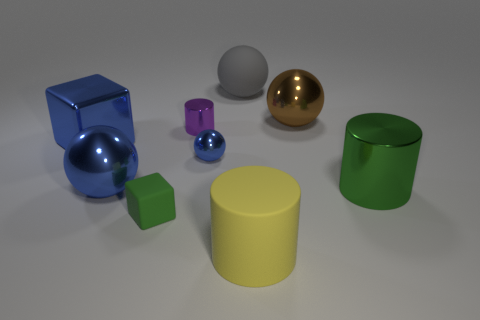What textures are visible on the objects, and how do they differ? The textures range from the reflective, smooth surface of the golden sphere to the matte, slightly bumpy surface of the green cylinder. There's a contrast between shiny and dull finishes among the objects. 